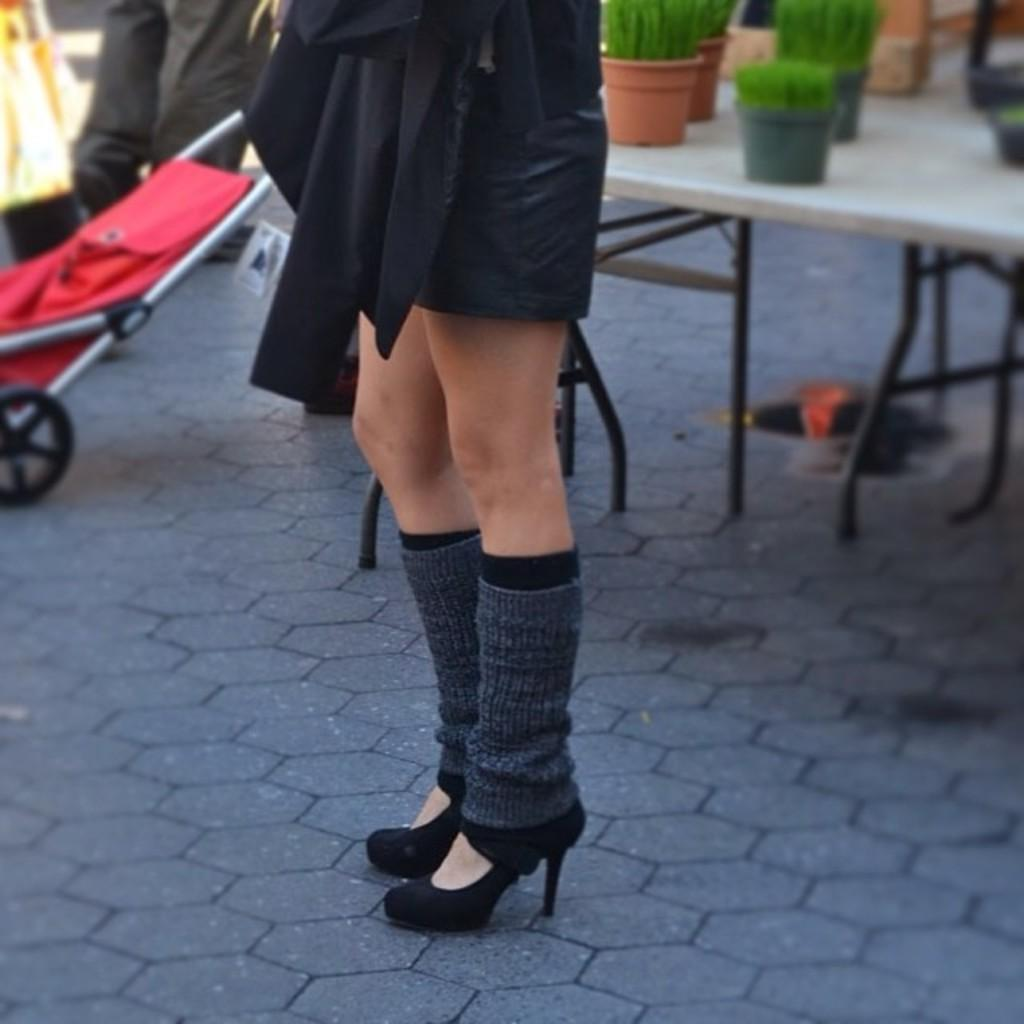What is located on the floor in the image? There are legs visible on the floor in the image. What else can be seen on the floor in the image? The provided facts do not mention any other objects on the floor. What is on the table in the image? There are potted plants on a table in the image. What type of furniture is present in the image? There is a stroller chair in the image. How many bulbs are hanging from the ceiling in the image? There is no mention of any bulbs or ceiling in the provided facts, so we cannot determine the number of bulbs in the image. 